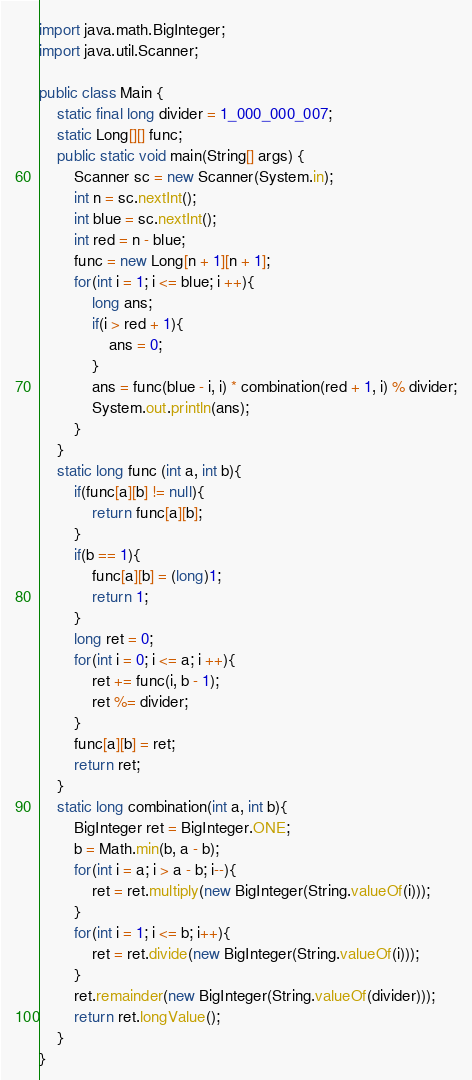<code> <loc_0><loc_0><loc_500><loc_500><_Java_>import java.math.BigInteger;
import java.util.Scanner;

public class Main {
	static final long divider = 1_000_000_007;
	static Long[][] func;
	public static void main(String[] args) {
		Scanner sc = new Scanner(System.in);
		int n = sc.nextInt();
		int blue = sc.nextInt();
		int red = n - blue;
		func = new Long[n + 1][n + 1];
		for(int i = 1; i <= blue; i ++){
			long ans;
			if(i > red + 1){
				ans = 0;
			}
			ans = func(blue - i, i) * combination(red + 1, i) % divider;
			System.out.println(ans);
		}
	}
	static long func (int a, int b){
		if(func[a][b] != null){
			return func[a][b];
		}
		if(b == 1){
			func[a][b] = (long)1;
			return 1;
		}
		long ret = 0;
		for(int i = 0; i <= a; i ++){
			ret += func(i, b - 1);
			ret %= divider;
		}
		func[a][b] = ret;
		return ret;
	}
	static long combination(int a, int b){
		BigInteger ret = BigInteger.ONE;
		b = Math.min(b, a - b);
		for(int i = a; i > a - b; i--){
			ret = ret.multiply(new BigInteger(String.valueOf(i)));
		}
		for(int i = 1; i <= b; i++){
			ret = ret.divide(new BigInteger(String.valueOf(i)));
		}
		ret.remainder(new BigInteger(String.valueOf(divider)));
		return ret.longValue();
	}
}
</code> 